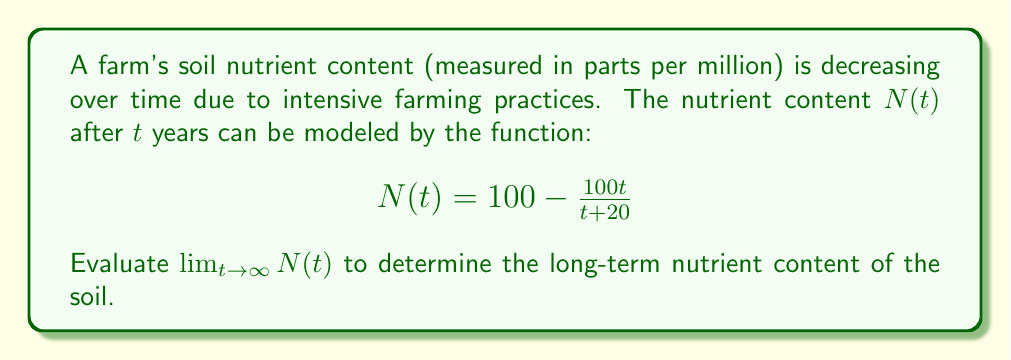Give your solution to this math problem. To evaluate this limit, we'll follow these steps:

1) First, let's examine the behavior of the function as $t$ approaches infinity:

   $$\lim_{t \to \infty} N(t) = \lim_{t \to \infty} \left(100 - \frac{100t}{t+20}\right)$$

2) We can't directly substitute infinity, so we need to manipulate the fraction:

   $$\lim_{t \to \infty} \left(100 - 100 \cdot \frac{t}{t+20}\right)$$

3) Divide both numerator and denominator by $t$:

   $$\lim_{t \to \infty} \left(100 - 100 \cdot \frac{1}{1+\frac{20}{t}}\right)$$

4) As $t$ approaches infinity, $\frac{20}{t}$ approaches 0:

   $$\lim_{t \to \infty} \left(100 - 100 \cdot \frac{1}{1+0}\right) = 100 - 100 \cdot 1 = 0$$

This result indicates that in the long term, the soil nutrient content will approach 0 parts per million, suggesting complete nutrient depletion if no intervention is made.
Answer: $\lim_{t \to \infty} N(t) = 0$ 